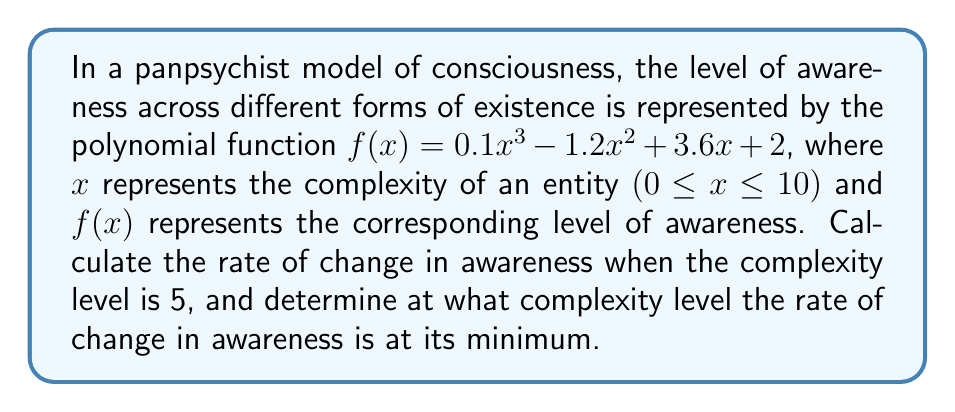Can you solve this math problem? To solve this problem, we need to use polynomial derivatives:

1. First, let's find the derivative of the given function:
   $f(x) = 0.1x^3 - 1.2x^2 + 3.6x + 2$
   $f'(x) = 0.3x^2 - 2.4x + 3.6$

2. To find the rate of change when complexity level is 5, we substitute x = 5 into $f'(x)$:
   $f'(5) = 0.3(5)^2 - 2.4(5) + 3.6$
   $f'(5) = 0.3(25) - 12 + 3.6$
   $f'(5) = 7.5 - 12 + 3.6 = -0.9$

3. To find the complexity level where the rate of change is at its minimum, we need to find the minimum point of $f'(x)$. Since $f'(x)$ is a quadratic function, its minimum occurs at the vertex of the parabola.

4. For a quadratic function in the form $ax^2 + bx + c$, the x-coordinate of the vertex is given by $x = -b/(2a)$:
   $a = 0.3$, $b = -2.4$
   $x = -(-2.4)/(2(0.3)) = 2.4/0.6 = 4$

Therefore, the rate of change in awareness is at its minimum when the complexity level is 4.
Answer: The rate of change in awareness when the complexity level is 5 is -0.9 units of awareness per unit of complexity. The rate of change in awareness is at its minimum when the complexity level is 4. 